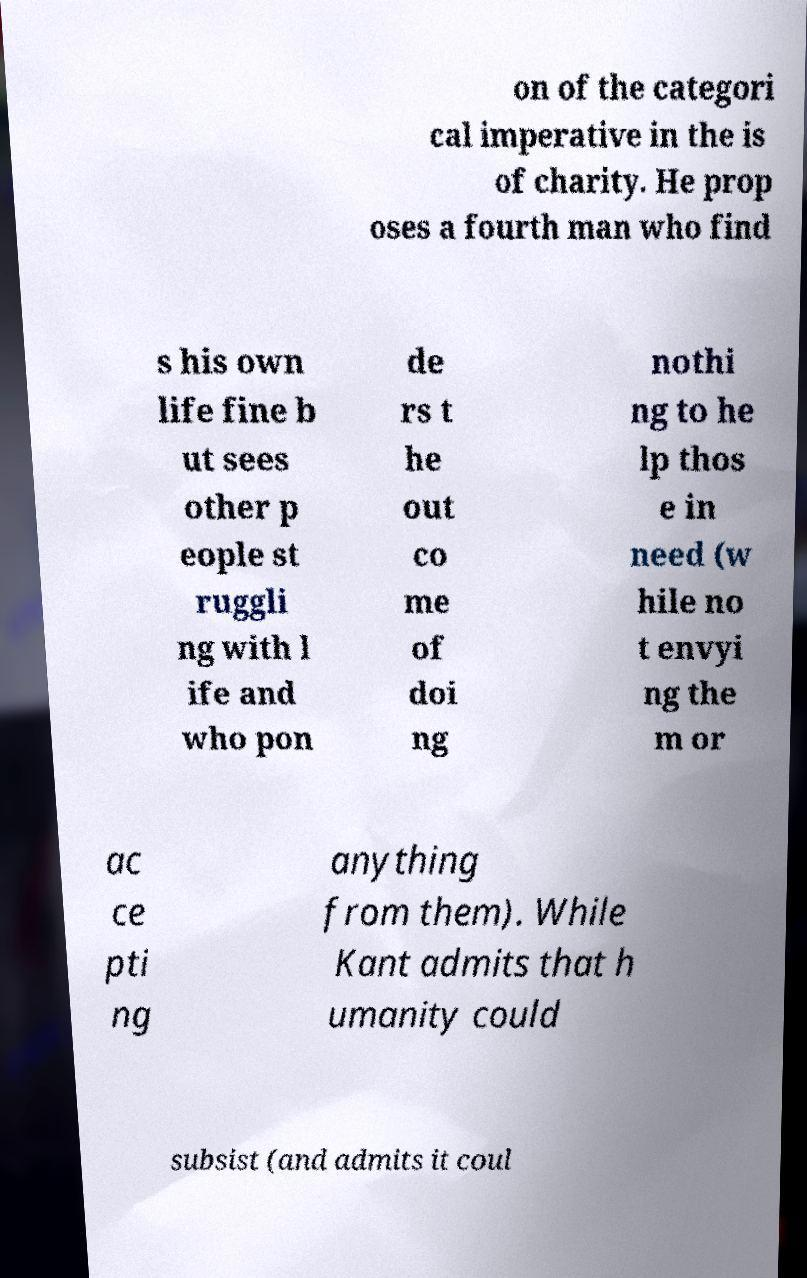Please identify and transcribe the text found in this image. on of the categori cal imperative in the is of charity. He prop oses a fourth man who find s his own life fine b ut sees other p eople st ruggli ng with l ife and who pon de rs t he out co me of doi ng nothi ng to he lp thos e in need (w hile no t envyi ng the m or ac ce pti ng anything from them). While Kant admits that h umanity could subsist (and admits it coul 